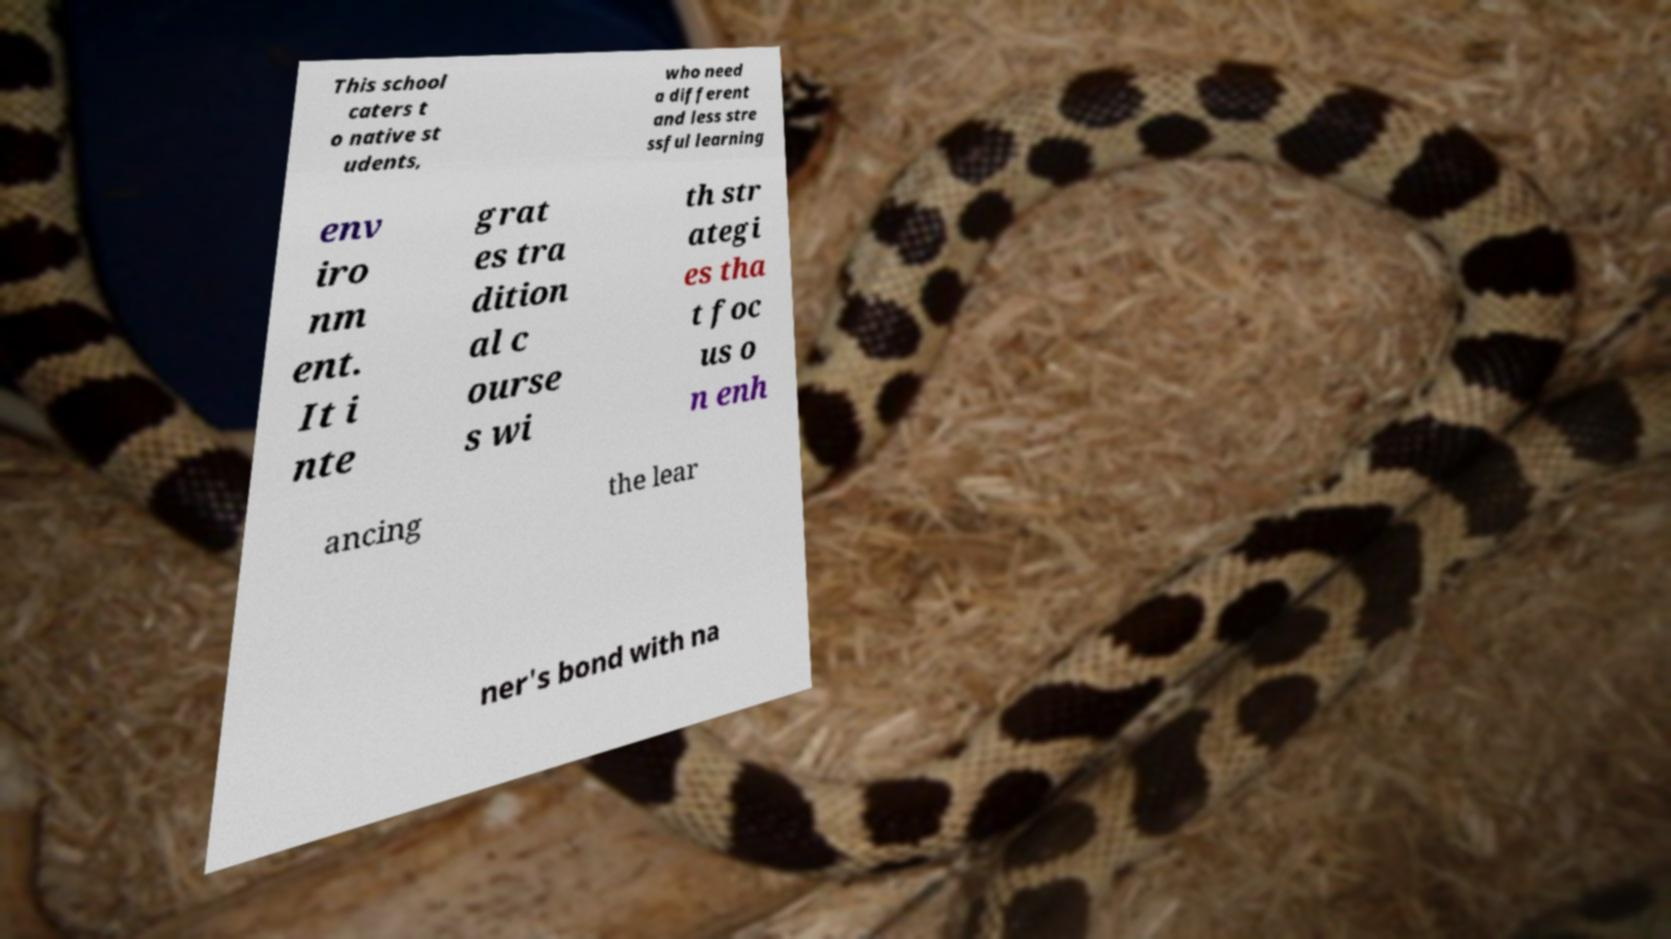Could you assist in decoding the text presented in this image and type it out clearly? This school caters t o native st udents, who need a different and less stre ssful learning env iro nm ent. It i nte grat es tra dition al c ourse s wi th str ategi es tha t foc us o n enh ancing the lear ner's bond with na 